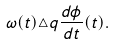<formula> <loc_0><loc_0><loc_500><loc_500>\omega ( t ) \triangle q { \frac { d \phi } { d t } } ( t ) .</formula> 